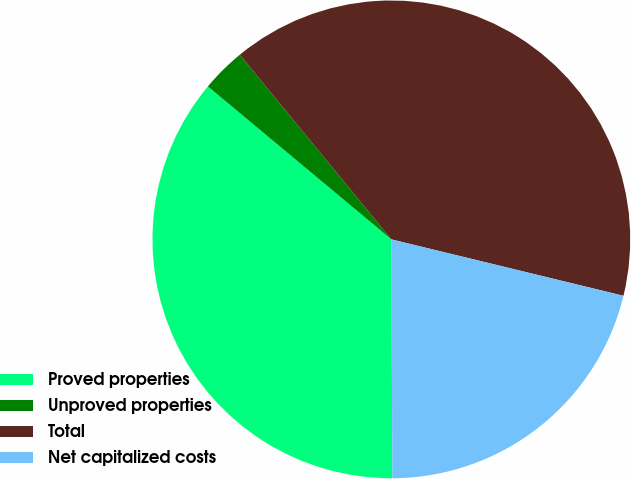Convert chart to OTSL. <chart><loc_0><loc_0><loc_500><loc_500><pie_chart><fcel>Proved properties<fcel>Unproved properties<fcel>Total<fcel>Net capitalized costs<nl><fcel>36.13%<fcel>3.0%<fcel>39.74%<fcel>21.14%<nl></chart> 